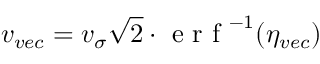Convert formula to latex. <formula><loc_0><loc_0><loc_500><loc_500>v _ { v e c } = v _ { \sigma } \sqrt { 2 } e r f ^ { - 1 } ( \eta _ { v e c } )</formula> 